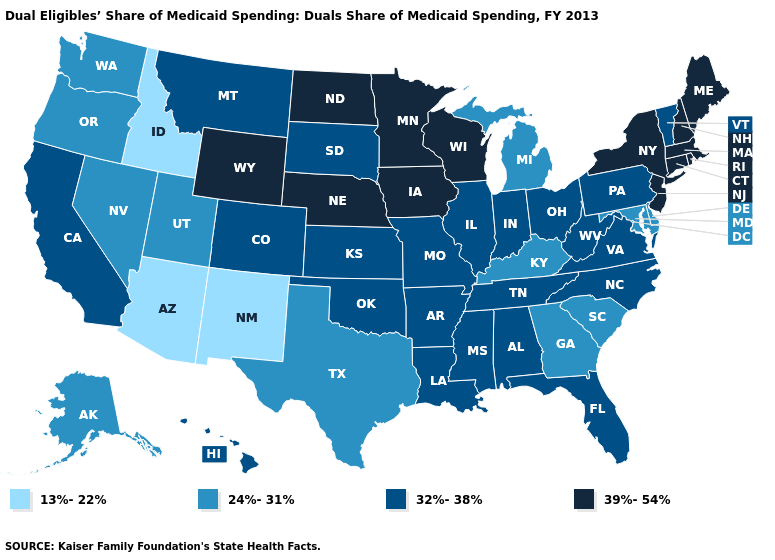Does Missouri have the same value as Florida?
Write a very short answer. Yes. Among the states that border New Mexico , does Texas have the lowest value?
Keep it brief. No. Among the states that border Vermont , which have the lowest value?
Short answer required. Massachusetts, New Hampshire, New York. Which states have the lowest value in the MidWest?
Concise answer only. Michigan. What is the value of Rhode Island?
Keep it brief. 39%-54%. Name the states that have a value in the range 24%-31%?
Answer briefly. Alaska, Delaware, Georgia, Kentucky, Maryland, Michigan, Nevada, Oregon, South Carolina, Texas, Utah, Washington. Does Pennsylvania have the highest value in the Northeast?
Write a very short answer. No. What is the value of Mississippi?
Quick response, please. 32%-38%. What is the value of Delaware?
Quick response, please. 24%-31%. Does the first symbol in the legend represent the smallest category?
Keep it brief. Yes. Name the states that have a value in the range 39%-54%?
Keep it brief. Connecticut, Iowa, Maine, Massachusetts, Minnesota, Nebraska, New Hampshire, New Jersey, New York, North Dakota, Rhode Island, Wisconsin, Wyoming. Among the states that border Utah , which have the lowest value?
Give a very brief answer. Arizona, Idaho, New Mexico. Does Kentucky have a lower value than Alaska?
Answer briefly. No. Does Kansas have a higher value than Georgia?
Give a very brief answer. Yes. What is the value of Massachusetts?
Answer briefly. 39%-54%. 